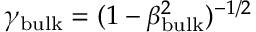<formula> <loc_0><loc_0><loc_500><loc_500>\gamma _ { b u l k } = ( 1 - \beta _ { b u l k } ^ { 2 } ) ^ { - 1 / 2 }</formula> 